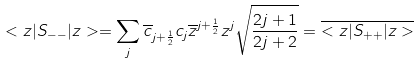<formula> <loc_0><loc_0><loc_500><loc_500>< z | S _ { - - } | z > = \sum _ { j } \overline { c } _ { j + \frac { 1 } { 2 } } c _ { j } \overline { z } ^ { j + \frac { 1 } { 2 } } z ^ { j } \sqrt { \frac { 2 j + 1 } { 2 j + 2 } } = \overline { < z | S _ { + + } | z > }</formula> 